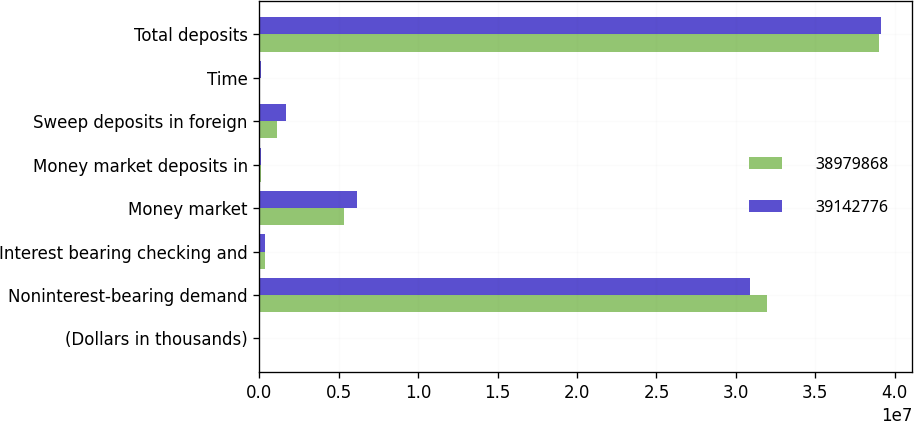Convert chart to OTSL. <chart><loc_0><loc_0><loc_500><loc_500><stacked_bar_chart><ecel><fcel>(Dollars in thousands)<fcel>Noninterest-bearing demand<fcel>Interest bearing checking and<fcel>Money market<fcel>Money market deposits in<fcel>Sweep deposits in foreign<fcel>Time<fcel>Total deposits<nl><fcel>3.89799e+07<fcel>2016<fcel>3.19755e+07<fcel>375710<fcel>5.33105e+06<fcel>107657<fcel>1.13387e+06<fcel>56118<fcel>3.89799e+07<nl><fcel>3.91428e+07<fcel>2015<fcel>3.08675e+07<fcel>330525<fcel>6.12844e+06<fcel>88656<fcel>1.65718e+06<fcel>70479<fcel>3.91428e+07<nl></chart> 